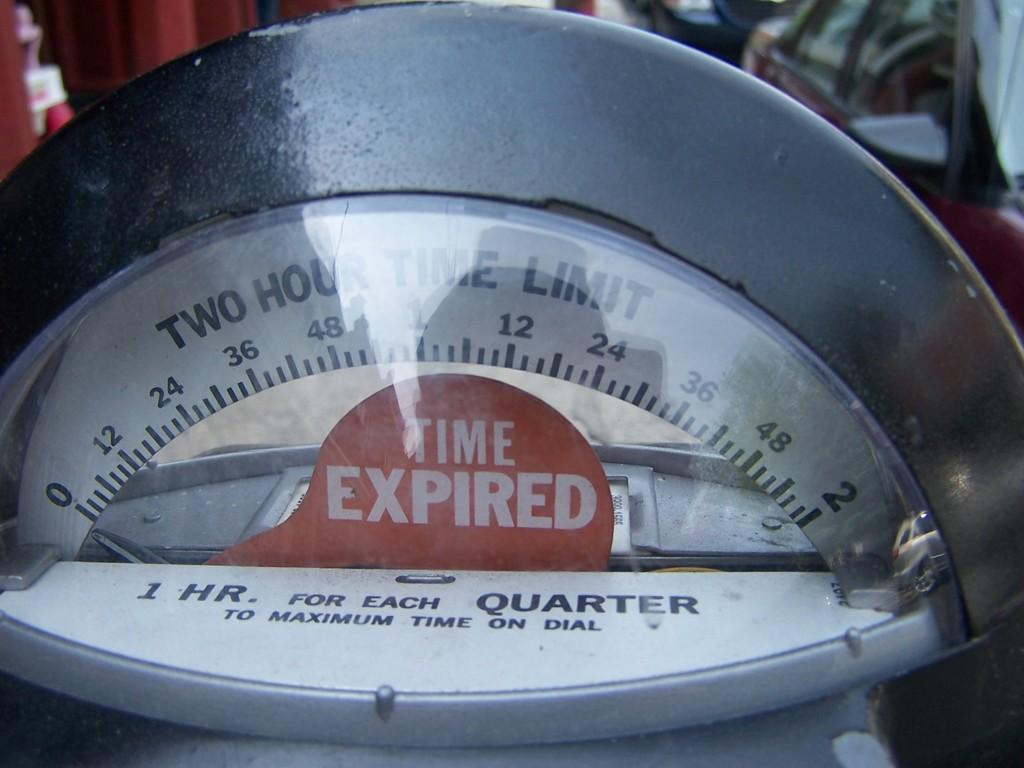<image>
Share a concise interpretation of the image provided. The parking meter takes quarters and is expired. 